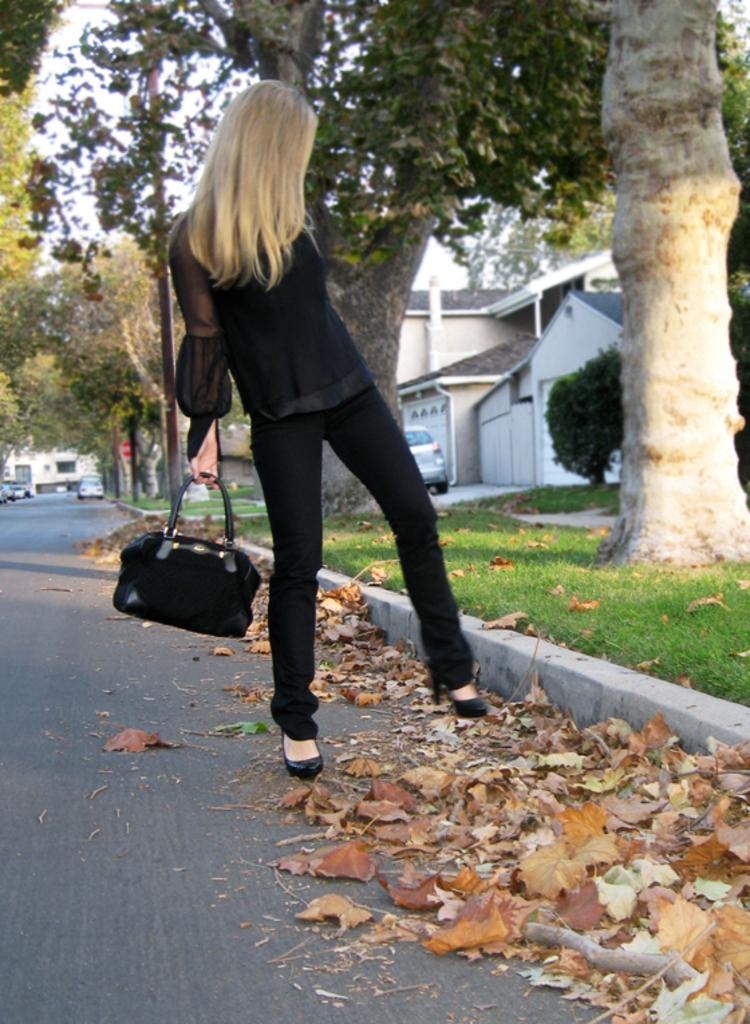What is the main subject of the image? There is a woman standing in the center of the image. What is the woman holding in the image? The woman is holding a handbag. What is the color of the handbag? The handbag is black in color. What can be seen in the background of the image? There is a building, trees, a plant, a vehicle, grass, and dry leaves visible in the background of the image. How many ladybugs are crawling on the woman's handbag in the image? There are no ladybugs visible on the woman's handbag in the image. How many houses are present in the background of the image? There is no mention of houses in the background of the image; only a building is mentioned. 